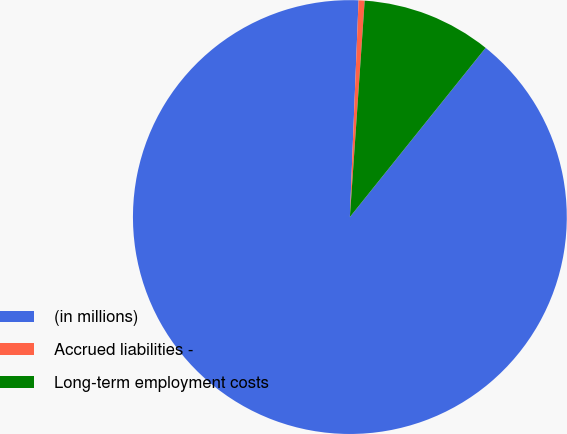Convert chart. <chart><loc_0><loc_0><loc_500><loc_500><pie_chart><fcel>(in millions)<fcel>Accrued liabilities -<fcel>Long-term employment costs<nl><fcel>89.88%<fcel>0.45%<fcel>9.67%<nl></chart> 